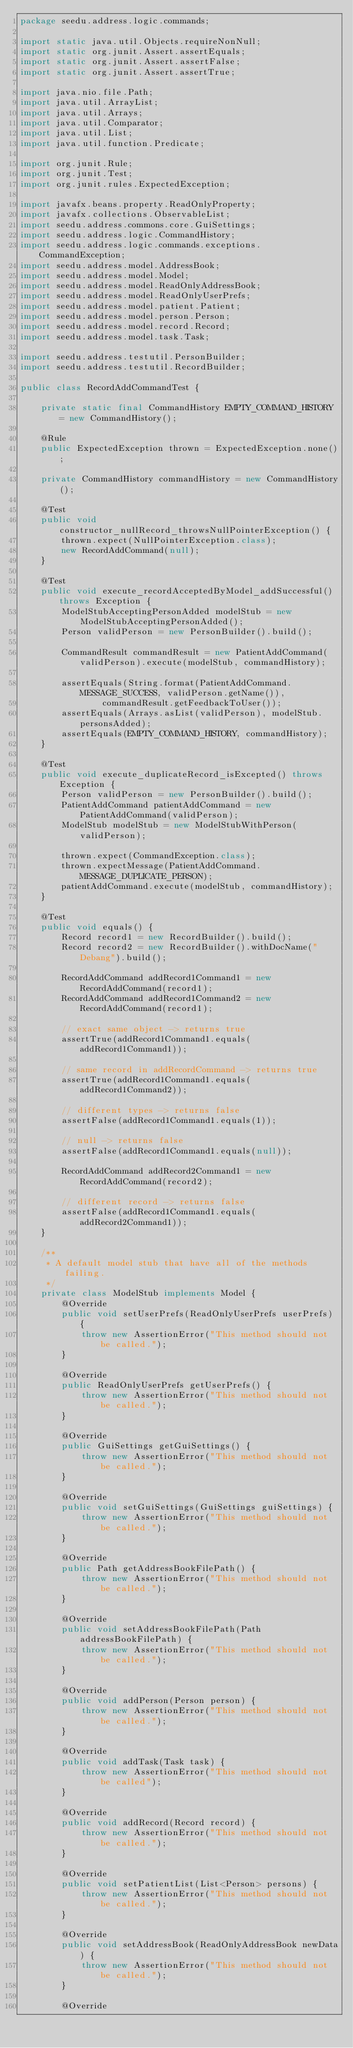<code> <loc_0><loc_0><loc_500><loc_500><_Java_>package seedu.address.logic.commands;

import static java.util.Objects.requireNonNull;
import static org.junit.Assert.assertEquals;
import static org.junit.Assert.assertFalse;
import static org.junit.Assert.assertTrue;

import java.nio.file.Path;
import java.util.ArrayList;
import java.util.Arrays;
import java.util.Comparator;
import java.util.List;
import java.util.function.Predicate;

import org.junit.Rule;
import org.junit.Test;
import org.junit.rules.ExpectedException;

import javafx.beans.property.ReadOnlyProperty;
import javafx.collections.ObservableList;
import seedu.address.commons.core.GuiSettings;
import seedu.address.logic.CommandHistory;
import seedu.address.logic.commands.exceptions.CommandException;
import seedu.address.model.AddressBook;
import seedu.address.model.Model;
import seedu.address.model.ReadOnlyAddressBook;
import seedu.address.model.ReadOnlyUserPrefs;
import seedu.address.model.patient.Patient;
import seedu.address.model.person.Person;
import seedu.address.model.record.Record;
import seedu.address.model.task.Task;

import seedu.address.testutil.PersonBuilder;
import seedu.address.testutil.RecordBuilder;

public class RecordAddCommandTest {

    private static final CommandHistory EMPTY_COMMAND_HISTORY = new CommandHistory();

    @Rule
    public ExpectedException thrown = ExpectedException.none();

    private CommandHistory commandHistory = new CommandHistory();

    @Test
    public void constructor_nullRecord_throwsNullPointerException() {
        thrown.expect(NullPointerException.class);
        new RecordAddCommand(null);
    }

    @Test
    public void execute_recordAcceptedByModel_addSuccessful() throws Exception {
        ModelStubAcceptingPersonAdded modelStub = new ModelStubAcceptingPersonAdded();
        Person validPerson = new PersonBuilder().build();

        CommandResult commandResult = new PatientAddCommand(validPerson).execute(modelStub, commandHistory);

        assertEquals(String.format(PatientAddCommand.MESSAGE_SUCCESS, validPerson.getName()),
                commandResult.getFeedbackToUser());
        assertEquals(Arrays.asList(validPerson), modelStub.personsAdded);
        assertEquals(EMPTY_COMMAND_HISTORY, commandHistory);
    }

    @Test
    public void execute_duplicateRecord_isExcepted() throws Exception {
        Person validPerson = new PersonBuilder().build();
        PatientAddCommand patientAddCommand = new PatientAddCommand(validPerson);
        ModelStub modelStub = new ModelStubWithPerson(validPerson);

        thrown.expect(CommandException.class);
        thrown.expectMessage(PatientAddCommand.MESSAGE_DUPLICATE_PERSON);
        patientAddCommand.execute(modelStub, commandHistory);
    }

    @Test
    public void equals() {
        Record record1 = new RecordBuilder().build();
        Record record2 = new RecordBuilder().withDocName("Debang").build();

        RecordAddCommand addRecord1Command1 = new RecordAddCommand(record1);
        RecordAddCommand addRecord1Command2 = new RecordAddCommand(record1);

        // exact same object -> returns true
        assertTrue(addRecord1Command1.equals(addRecord1Command1));

        // same record in addRecordCommand -> returns true
        assertTrue(addRecord1Command1.equals(addRecord1Command2));

        // different types -> returns false
        assertFalse(addRecord1Command1.equals(1));

        // null -> returns false
        assertFalse(addRecord1Command1.equals(null));

        RecordAddCommand addRecord2Command1 = new RecordAddCommand(record2);

        // different record -> returns false
        assertFalse(addRecord1Command1.equals(addRecord2Command1));
    }

    /**
     * A default model stub that have all of the methods failing.
     */
    private class ModelStub implements Model {
        @Override
        public void setUserPrefs(ReadOnlyUserPrefs userPrefs) {
            throw new AssertionError("This method should not be called.");
        }

        @Override
        public ReadOnlyUserPrefs getUserPrefs() {
            throw new AssertionError("This method should not be called.");
        }

        @Override
        public GuiSettings getGuiSettings() {
            throw new AssertionError("This method should not be called.");
        }

        @Override
        public void setGuiSettings(GuiSettings guiSettings) {
            throw new AssertionError("This method should not be called.");
        }

        @Override
        public Path getAddressBookFilePath() {
            throw new AssertionError("This method should not be called.");
        }

        @Override
        public void setAddressBookFilePath(Path addressBookFilePath) {
            throw new AssertionError("This method should not be called.");
        }

        @Override
        public void addPerson(Person person) {
            throw new AssertionError("This method should not be called.");
        }

        @Override
        public void addTask(Task task) {
            throw new AssertionError("This method should not be called");
        }

        @Override
        public void addRecord(Record record) {
            throw new AssertionError("This method should not be called.");
        }

        @Override
        public void setPatientList(List<Person> persons) {
            throw new AssertionError("This method should not be called.");
        }

        @Override
        public void setAddressBook(ReadOnlyAddressBook newData) {
            throw new AssertionError("This method should not be called.");
        }

        @Override</code> 